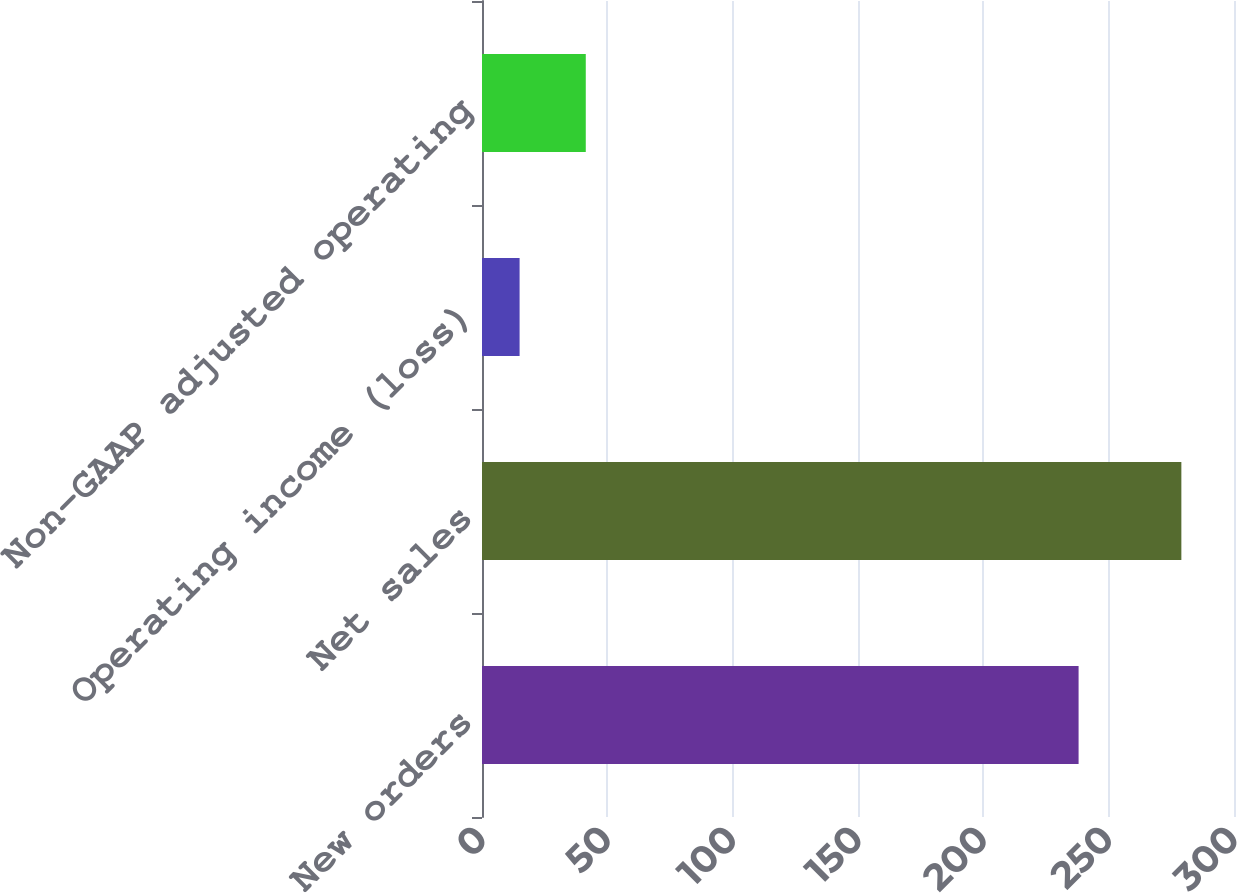Convert chart. <chart><loc_0><loc_0><loc_500><loc_500><bar_chart><fcel>New orders<fcel>Net sales<fcel>Operating income (loss)<fcel>Non-GAAP adjusted operating<nl><fcel>238<fcel>279<fcel>15<fcel>41.4<nl></chart> 